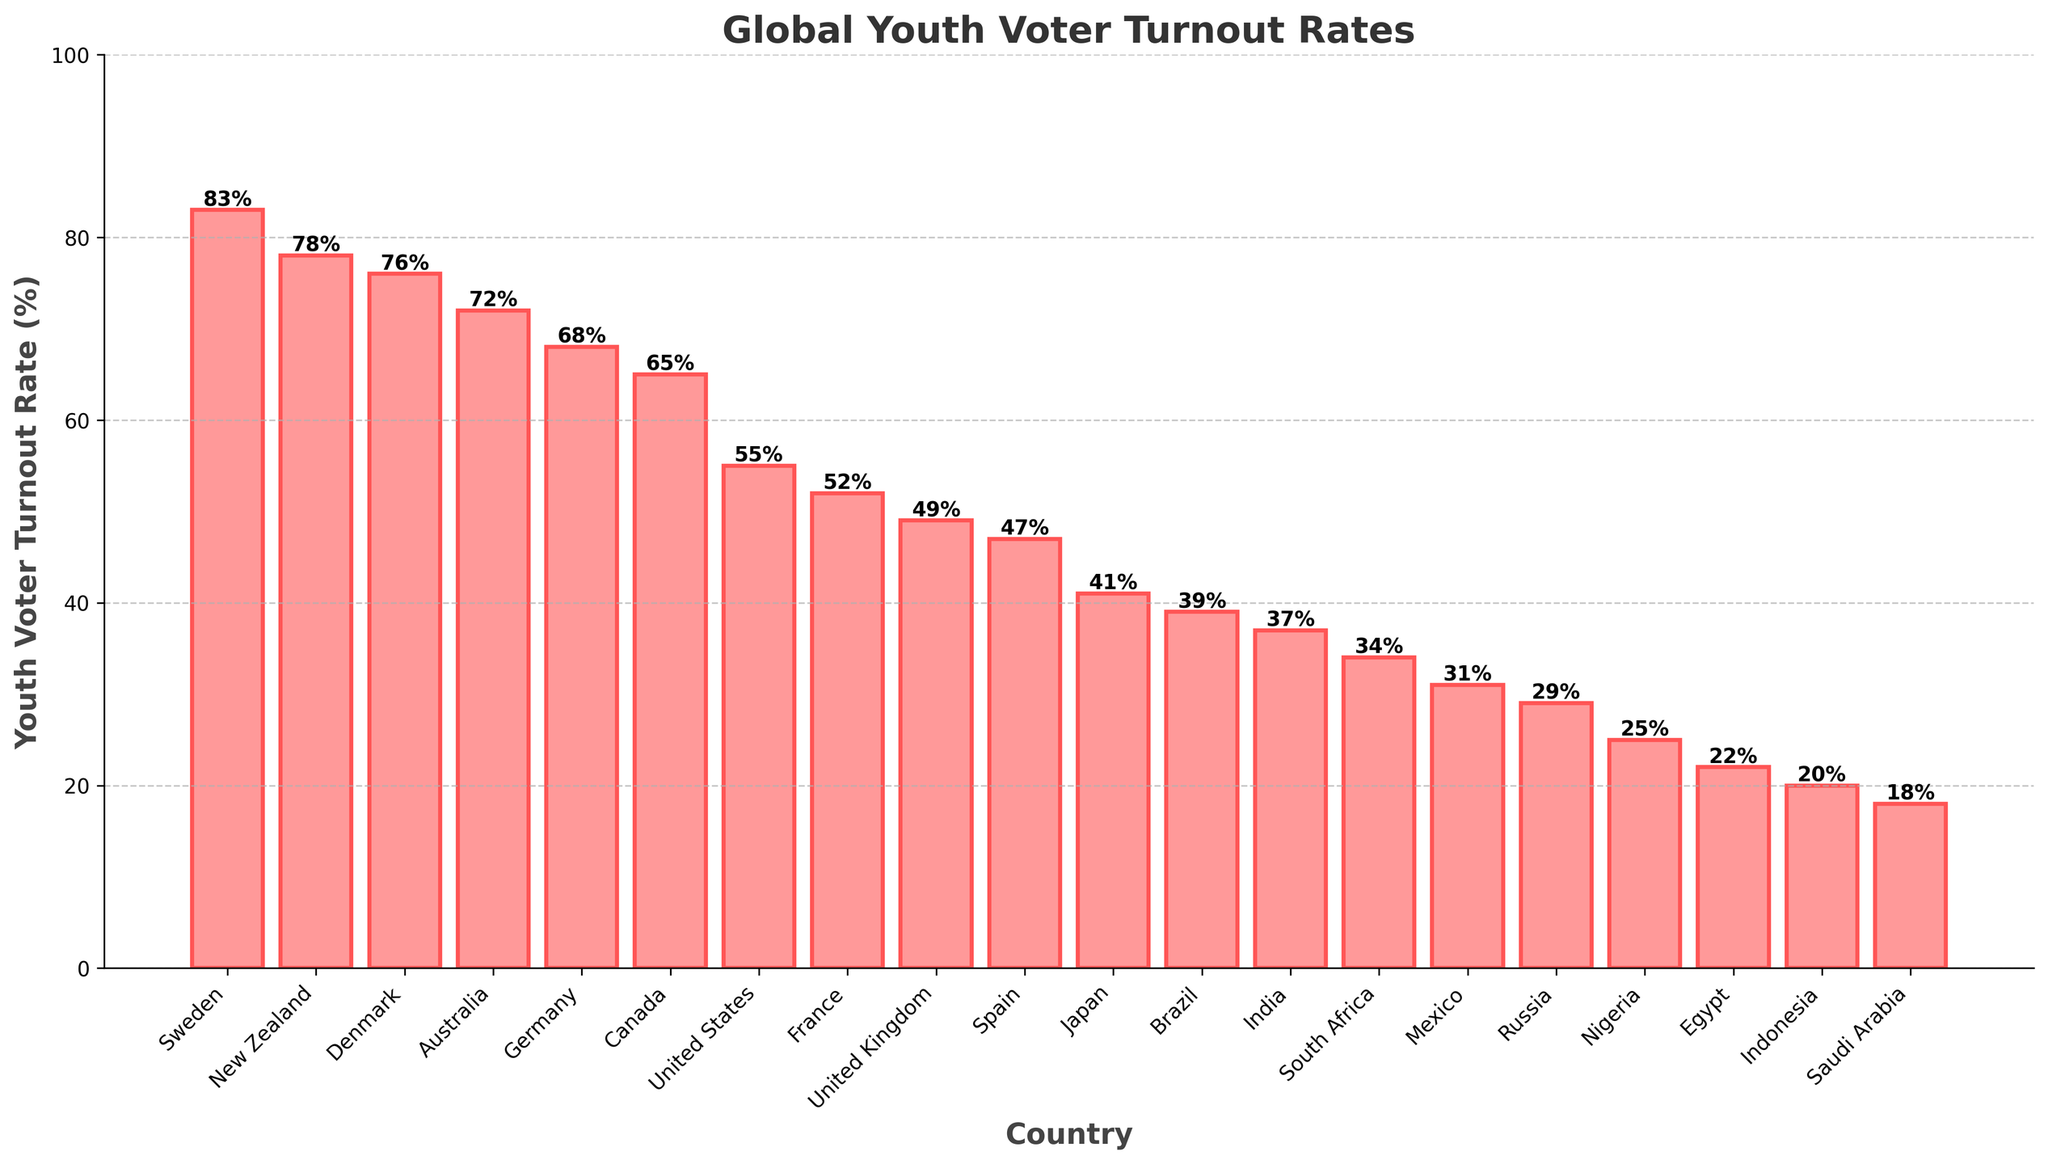What's the country with the highest youth voter turnout rate? Look for the highest bar in the chart and read the associated country's name.
Answer: Sweden What's the difference in voter turnout between the country with the highest and lowest youth voter turnout rates? Find the height of the highest bar (Sweden: 83%) and the lowest bar (Saudi Arabia: 18%), and subtract the lower value from the higher value: 83 - 18.
Answer: 65% Which country has a youth voter turnout rate higher than 70% but less than 80%? Identify the bars within the 70%-80% range: New Zealand (78%), Denmark (76%), and Australia (72%).
Answer: New Zealand, Denmark, Australia How many countries have a youth voter turnout rate below 50%? Count the number of bars that have a height less than 50%. These are: United Kingdom, Spain, Japan, Brazil, India, South Africa, Mexico, Russia, Nigeria, Egypt, Indonesia, and Saudi Arabia – which makes a total of 12 countries.
Answer: 12 Compare the youth voter turnout rates of Germany and the United States, which country has a higher rate and by how much? Read the values: Germany (68%) and United States (55%). Then, subtract the lower value from the higher value: 68 - 55.
Answer: Germany by 13% What is the average youth voter turnout rate of the countries shown? Add up all the voter turnout rates and divide by the number of countries: (83 + 78 + 76 + 72 + 68 + 65 + 55 + 52 + 49 + 47 + 41 + 39 + 37 + 34 + 31 + 29 + 25 + 22 + 20 + 18) / 20 = 45.1%
Answer: 45.1% What's the difference in the youth voter turnout rates between countries with the lowest (Saudi Arabia) and the second lowest (Indonesia) rates? Find the heights of the two lowest bars: Saudi Arabia (18%) and Indonesia (20%). Then, subtract the lower value from the higher value: 20 - 18.
Answer: 2% Which countries have an equal youth voter turnout rate? Look for bars of the same height. None of the countries have bars of the exact same height.
Answer: None Among the countries listed, which country has a rate closest to the global average rate? Calculate the average rate from the previous question (45.1%) and find the turnout rate closest to it. The closest is Spain (47%).
Answer: Spain Which two countries have the highest and second highest youth voter turnout rates, and what percentage point difference is there between them? Identify the highest and second highest bars: Sweden (83%) and New Zealand (78%). Subtract the second-highest rate from the highest: 83 - 78.
Answer: Sweden and New Zealand, 5% 